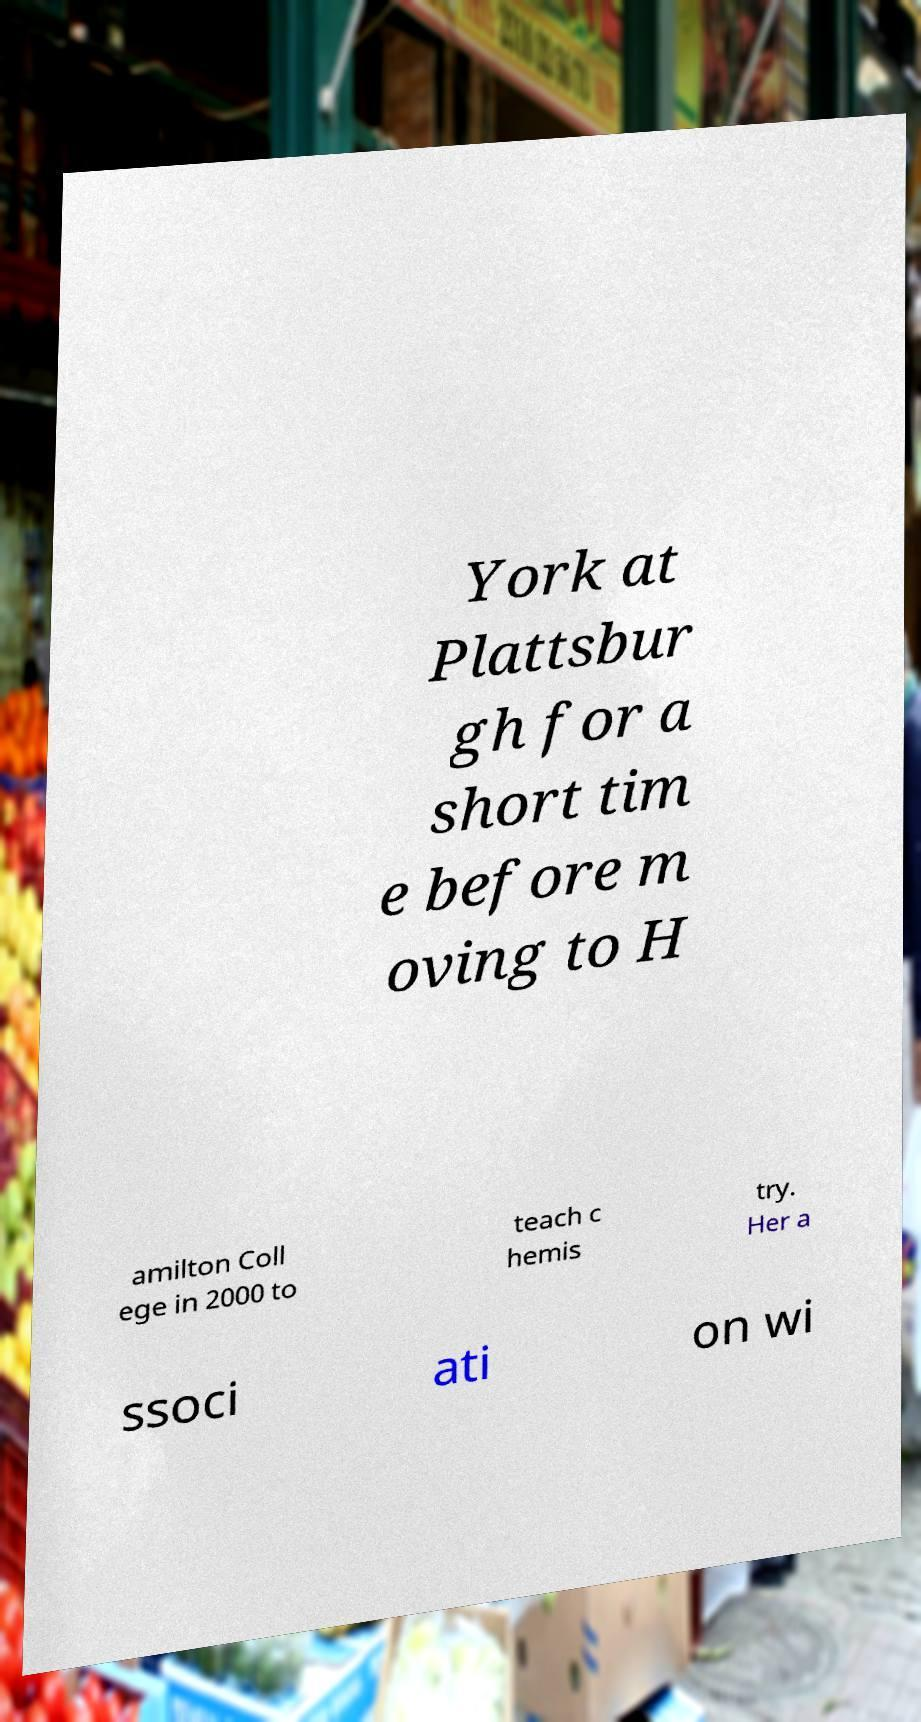Please read and relay the text visible in this image. What does it say? York at Plattsbur gh for a short tim e before m oving to H amilton Coll ege in 2000 to teach c hemis try. Her a ssoci ati on wi 